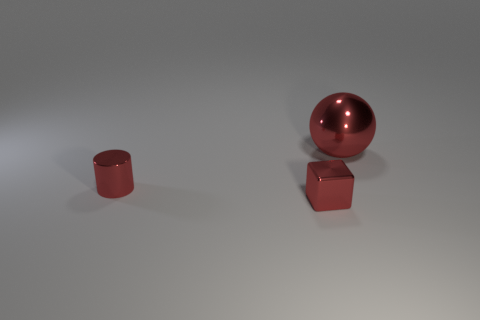Can you describe the size difference between the objects in the image? Certainly! In the image, there are three objects, and the sphere appears to be the largest. It is followed in size by the cylinder, which is medium-sized, and the smallest is the cube. The sphere's diameter looks about twice the height of the cylinder, and the cube is slightly shorter than the cylinder's height. 